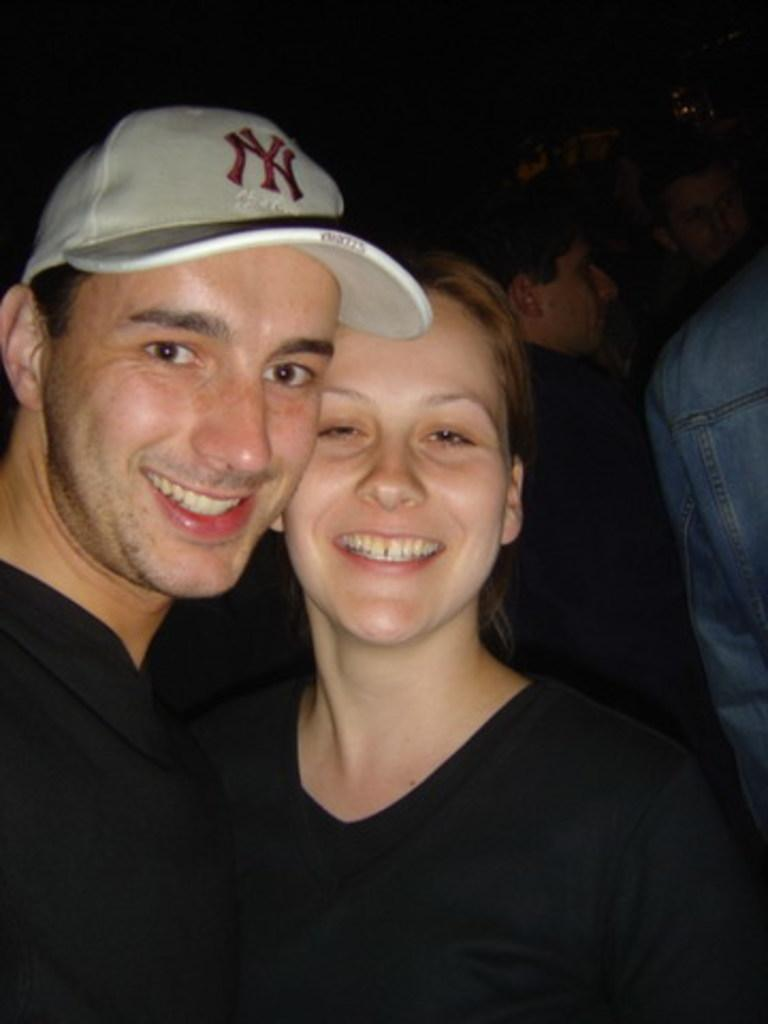What can be seen in the image? There is a group of people in the image. Can you describe the people in the image? There is a woman and a man in the image. What expressions do the woman and man have? The woman and the man are both smiling. What is the man wearing on his head? The man is wearing a cap. What type of vacation is the man planning to take with his slave in the image? There is no mention of a vacation or a slave in the image; it only shows a smiling woman and a man wearing a cap. 